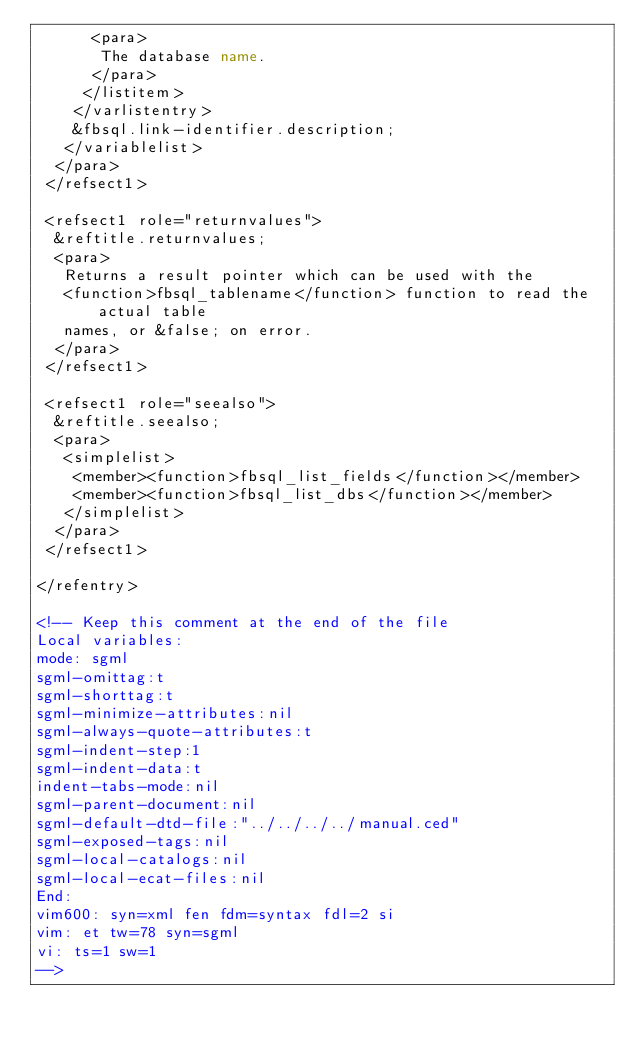<code> <loc_0><loc_0><loc_500><loc_500><_XML_>      <para>
       The database name.
      </para>
     </listitem>
    </varlistentry>
    &fbsql.link-identifier.description;
   </variablelist>
  </para>
 </refsect1>

 <refsect1 role="returnvalues">
  &reftitle.returnvalues;
  <para>
   Returns a result pointer which can be used with the
   <function>fbsql_tablename</function> function to read the actual table
   names, or &false; on error.
  </para>
 </refsect1>

 <refsect1 role="seealso">
  &reftitle.seealso;
  <para>
   <simplelist>
    <member><function>fbsql_list_fields</function></member>
    <member><function>fbsql_list_dbs</function></member>
   </simplelist>
  </para>
 </refsect1>

</refentry>

<!-- Keep this comment at the end of the file
Local variables:
mode: sgml
sgml-omittag:t
sgml-shorttag:t
sgml-minimize-attributes:nil
sgml-always-quote-attributes:t
sgml-indent-step:1
sgml-indent-data:t
indent-tabs-mode:nil
sgml-parent-document:nil
sgml-default-dtd-file:"../../../../manual.ced"
sgml-exposed-tags:nil
sgml-local-catalogs:nil
sgml-local-ecat-files:nil
End:
vim600: syn=xml fen fdm=syntax fdl=2 si
vim: et tw=78 syn=sgml
vi: ts=1 sw=1
-->
</code> 